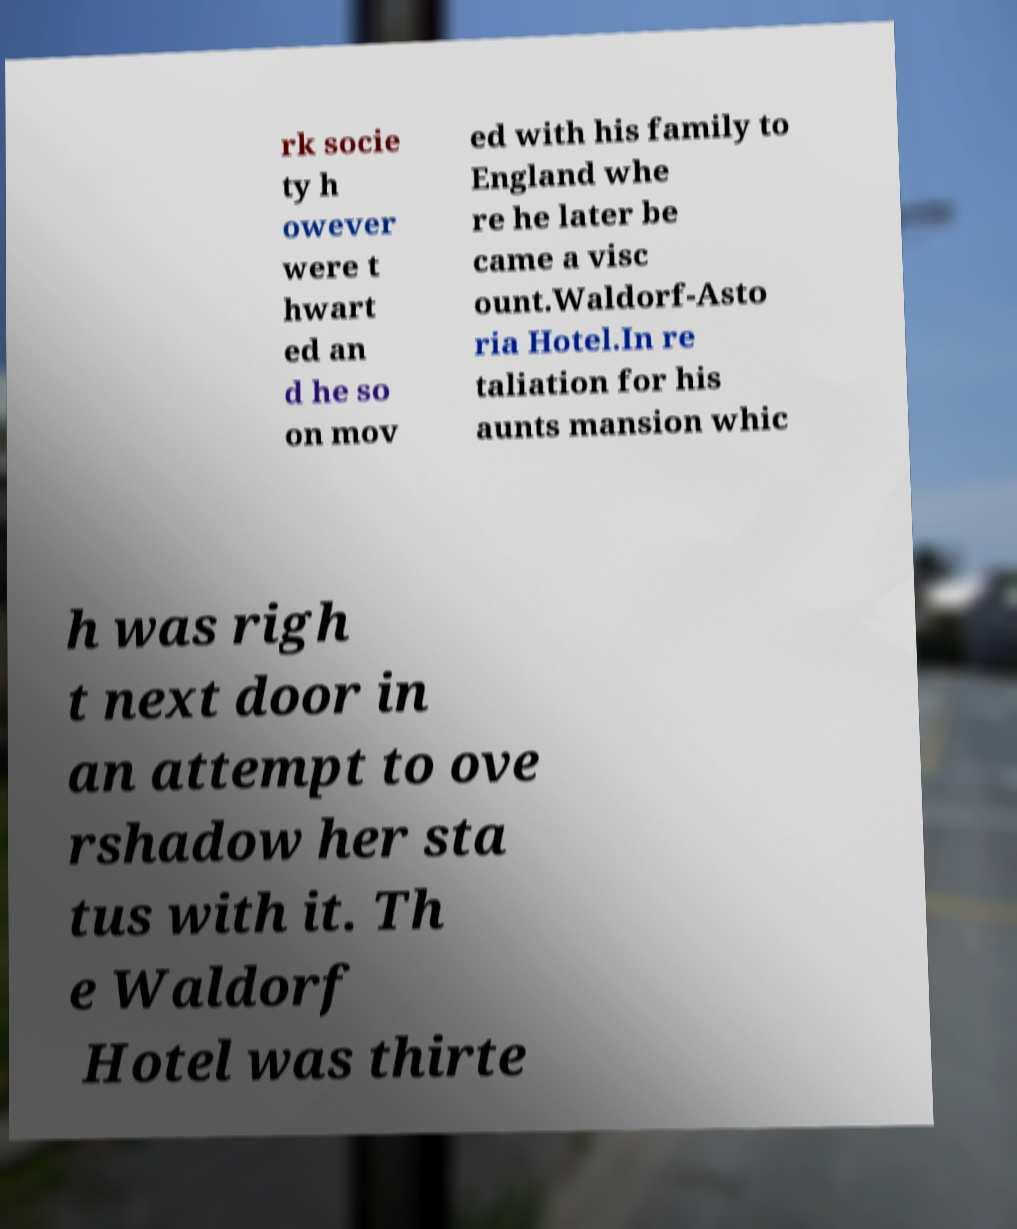I need the written content from this picture converted into text. Can you do that? rk socie ty h owever were t hwart ed an d he so on mov ed with his family to England whe re he later be came a visc ount.Waldorf-Asto ria Hotel.In re taliation for his aunts mansion whic h was righ t next door in an attempt to ove rshadow her sta tus with it. Th e Waldorf Hotel was thirte 